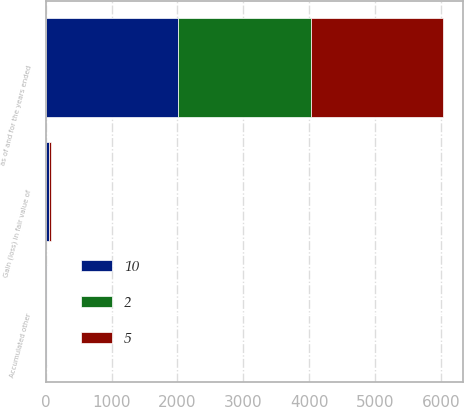<chart> <loc_0><loc_0><loc_500><loc_500><stacked_bar_chart><ecel><fcel>as of and for the years ended<fcel>Gain (loss) in fair value of<fcel>Accumulated other<nl><fcel>10<fcel>2013<fcel>41<fcel>10<nl><fcel>2<fcel>2012<fcel>7<fcel>5<nl><fcel>5<fcel>2011<fcel>31<fcel>2<nl></chart> 